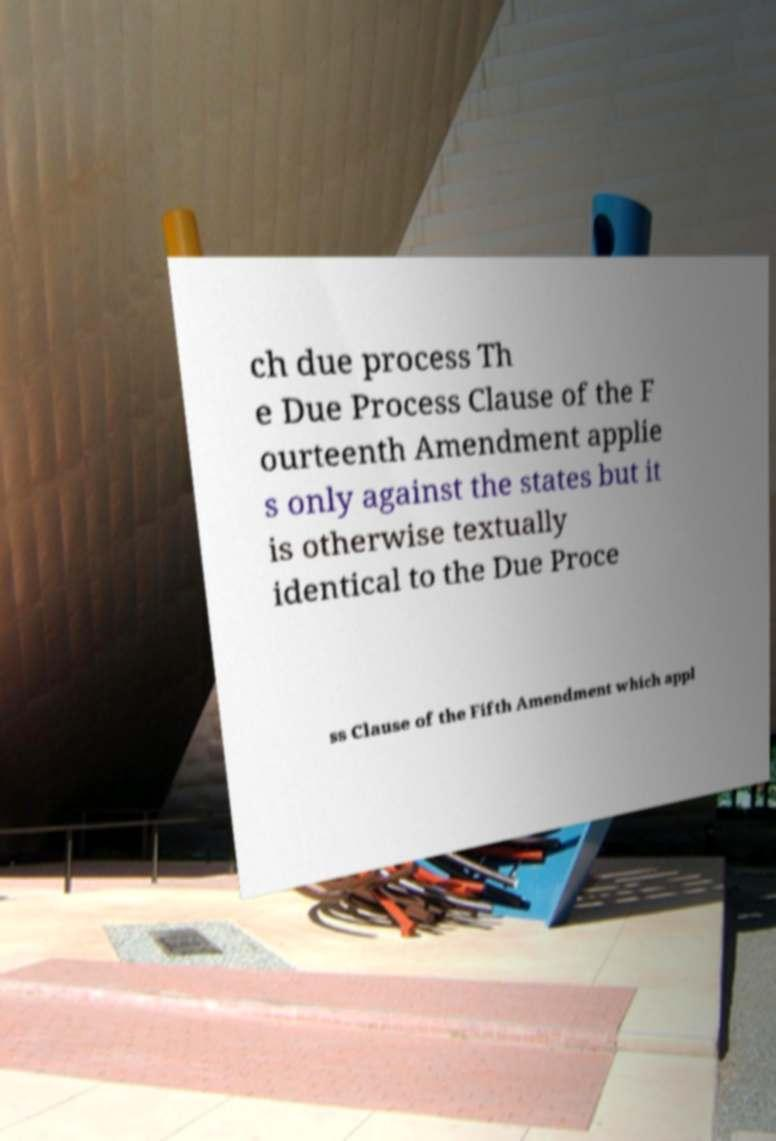Could you extract and type out the text from this image? ch due process Th e Due Process Clause of the F ourteenth Amendment applie s only against the states but it is otherwise textually identical to the Due Proce ss Clause of the Fifth Amendment which appl 